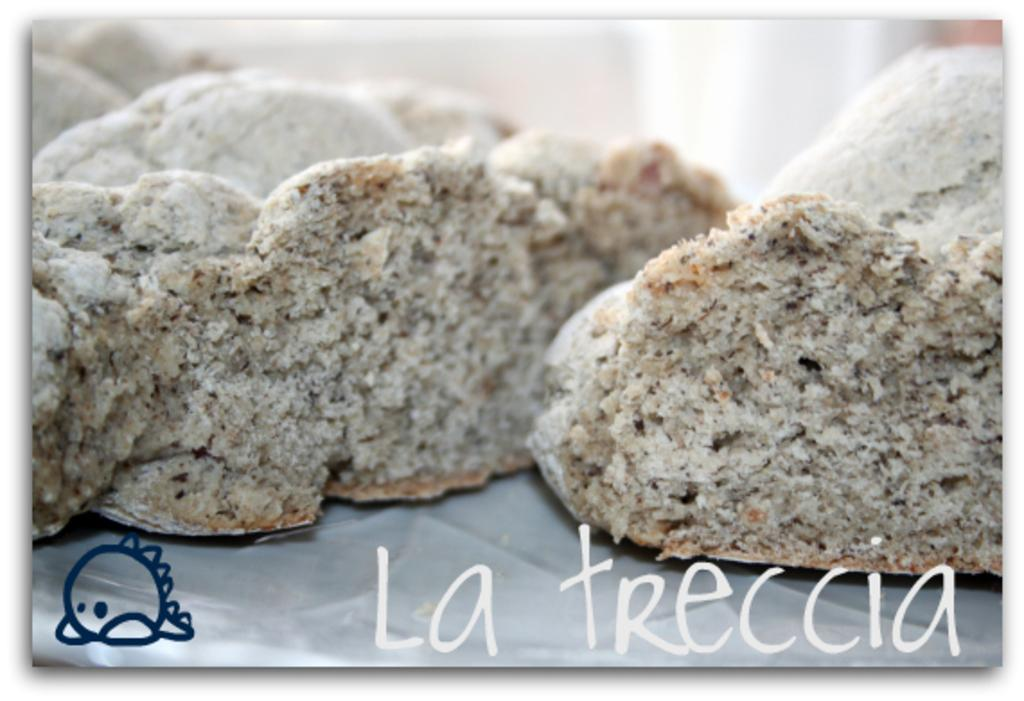What can be seen at the bottom of the image? There are watermarks at the bottom of the image. What is the main subject of the image? There are food items arranged on a surface in the middle of the image. How would you describe the background of the image? The background of the image is blurred. Where is the hospital located in the image? There is no hospital present in the image. Can you see a sink in the image? There is no sink visible in the image. 